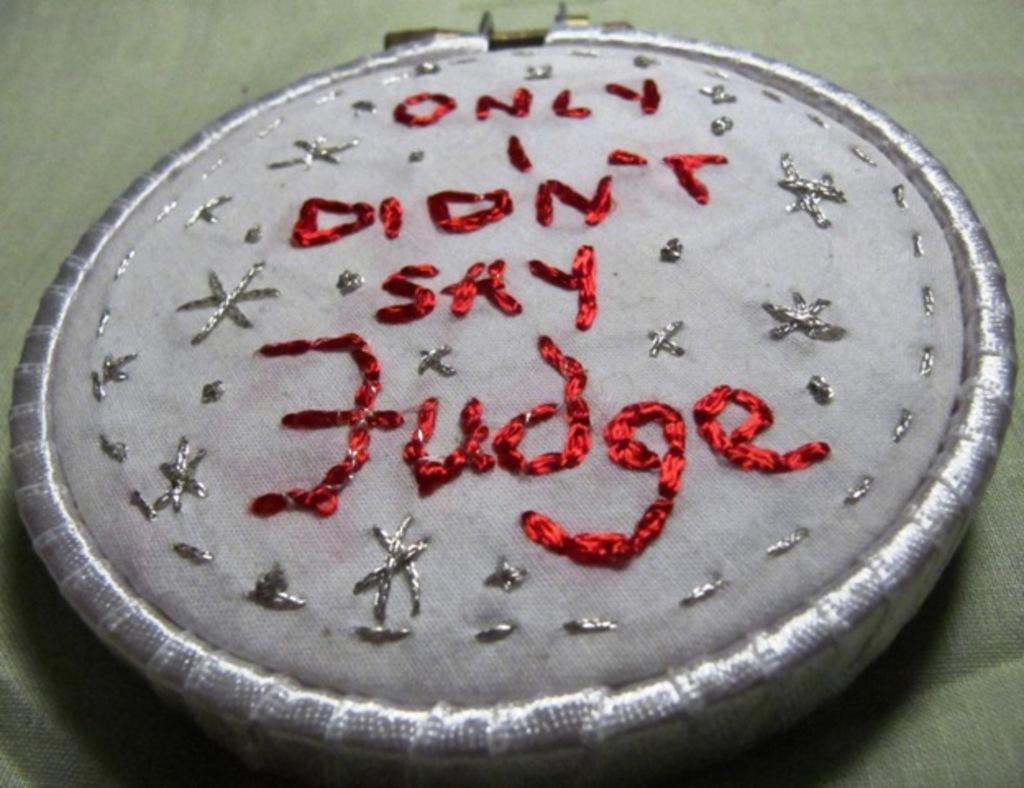Please provide a concise description of this image. In the image there is a quotation made with the help of threads on an object, it is written with red color thread. 